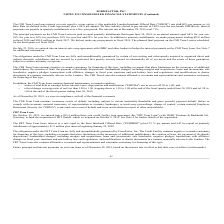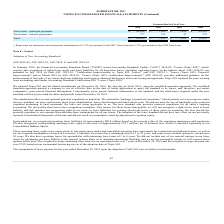According to Formfactor's financial document, When was FRT GmbH acquired? According to the financial document, October 9, 2019. The relevant text states: "the acquisition of FRT GmbH, which we acquired on October 9, 2019. See Note 4 for further details of the acquisition...." Also, can you calculate: What is the change in Term loans - principal payments from Fiscal Year 2021 to 2020? Based on the calculation: 7,838-42,838, the result is -35000 (in thousands). This is based on the information: "Term loans - principal payments $ 42,838 $ 7,838 $ 7,838 $ 58,514 Term loans - principal payments $ 42,838 $ 7,838 $ 7,838 $ 58,514..." The key data points involved are: 42,838, 7,838. Also, can you calculate: What is the change in Term loans - interest payments from Fiscal Year 2021 to 2020? Based on the calculation: 155-777, the result is -622 (in thousands). This is based on the information: "Term loans - interest payments (1) 777 155 47 979 Term loans - interest payments (1) 777 155 47 979..." The key data points involved are: 155, 777. Additionally, In which year was Term loans - principal payments less than 10,000 thousands? The document shows two values: 2021 and 2022. Locate and analyze term loans - principal payments in row 3. From the document: "2020 2021 2022 Total 2020 2021 2022 Total..." Also, What was the Term loans - interest payments in 2020, 2021 and 2022 respectively? The document contains multiple relevant values: 777, 155, 47 (in thousands). From the document: "Term loans - interest payments (1) 777 155 47 979 Term loans - interest payments (1) 777 155 47 979 Term loans - interest payments (1) 777 155 47 979..." Also, What was the credit facility loan amount entered on October 25, 2019? According to the financial document, $23.4 million. The relevant text states: "T Term Loan On October 25, 2019, we entered into a $23.4 million three-year credit facility loan agreement (the "FRT Term Loan") with HSBC Trinkaus & Burkhardt AG, G..." 